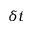<formula> <loc_0><loc_0><loc_500><loc_500>\delta t</formula> 